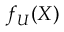Convert formula to latex. <formula><loc_0><loc_0><loc_500><loc_500>f _ { U } ( X )</formula> 